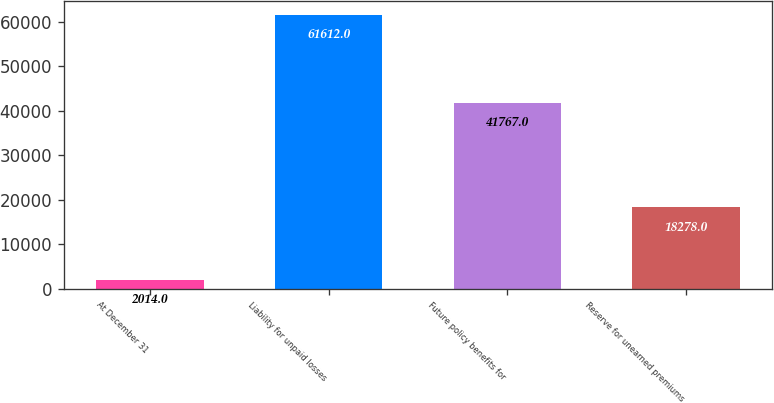Convert chart. <chart><loc_0><loc_0><loc_500><loc_500><bar_chart><fcel>At December 31<fcel>Liability for unpaid losses<fcel>Future policy benefits for<fcel>Reserve for unearned premiums<nl><fcel>2014<fcel>61612<fcel>41767<fcel>18278<nl></chart> 